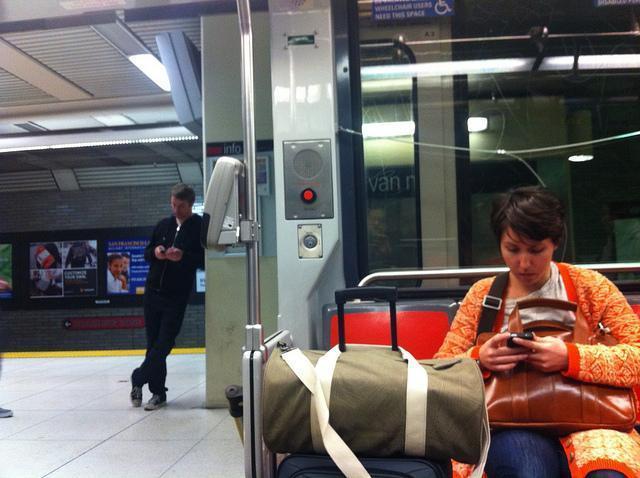How many people are there?
Give a very brief answer. 2. How many handbags are visible?
Give a very brief answer. 2. 